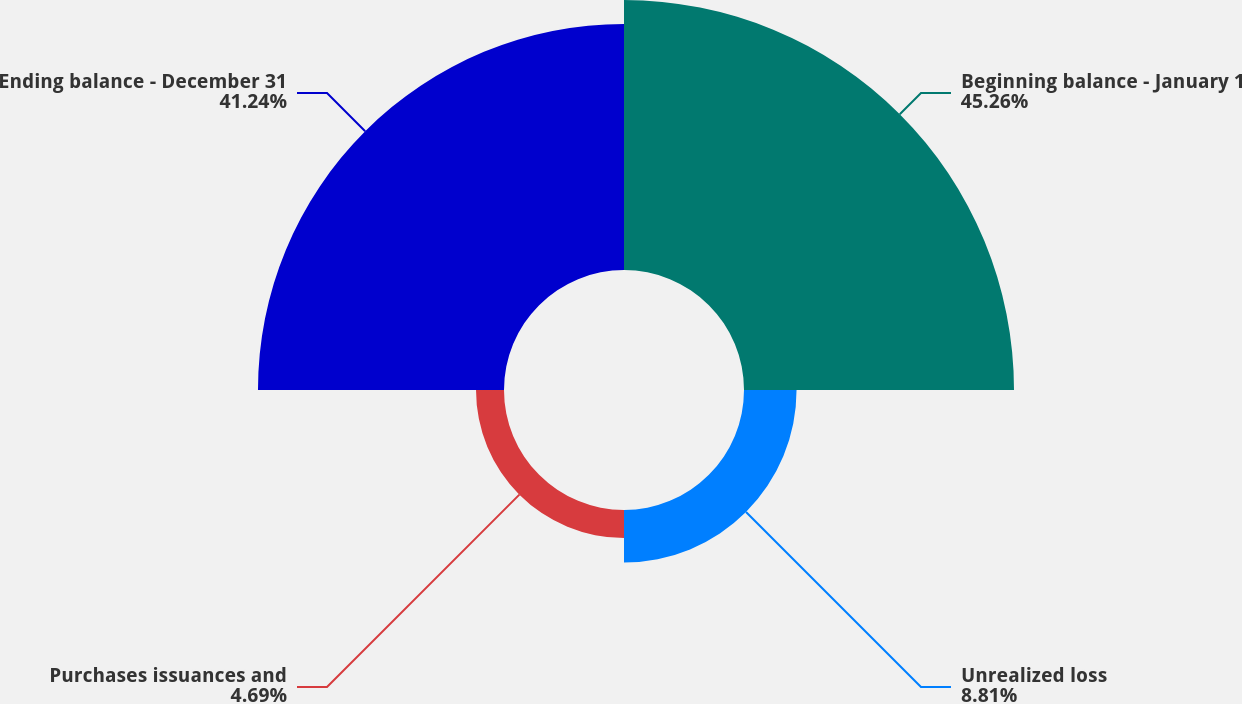<chart> <loc_0><loc_0><loc_500><loc_500><pie_chart><fcel>Beginning balance - January 1<fcel>Unrealized loss<fcel>Purchases issuances and<fcel>Ending balance - December 31<nl><fcel>45.26%<fcel>8.81%<fcel>4.69%<fcel>41.24%<nl></chart> 